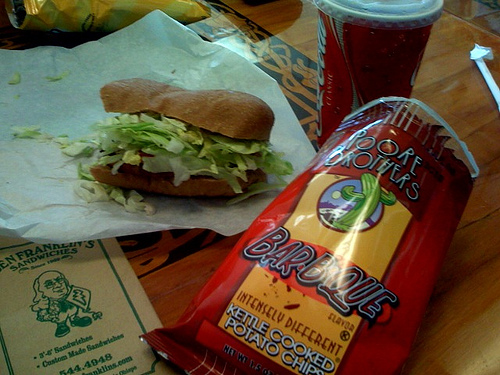<image>What is the name of the Market? I am not sure what the name of the Market is. It could either be 'poore brothers' or "ben franklin's sandwiches", or something else. What is the name of the Market? I don't know the name of the Market. It can be 'poore brothers' or "ben franklin's sandwiches". 